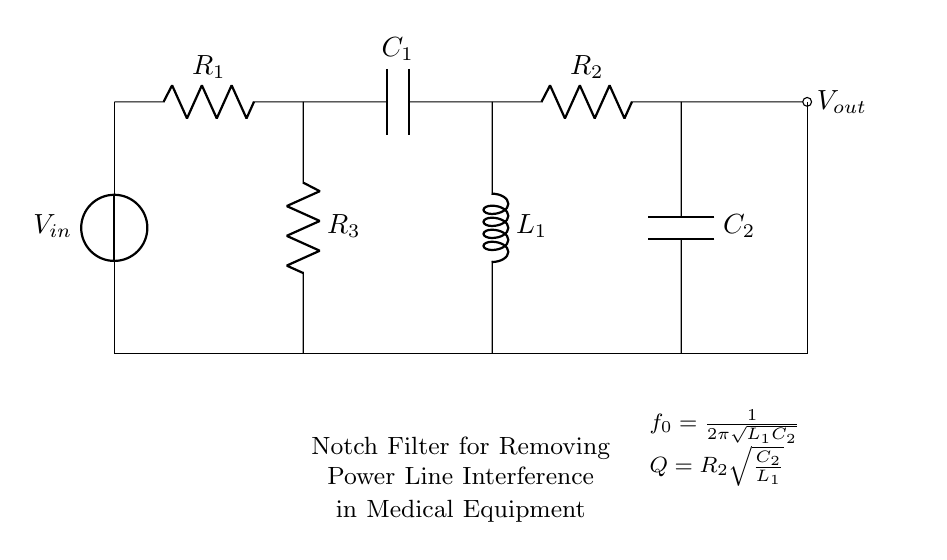What is the input voltage symbol in this circuit? The input voltage is represented by the symbol V_in, indicating the point where the voltage is applied to the circuit.
Answer: V_in What is the output voltage node labeled as? The output voltage node is indicated with the label V_out, which shows where the filtered signal will be taken from the circuit.
Answer: V_out How many resistors are present in the circuit? There are three resistors shown in the circuit: R_1, R_2, and R_3, which are used for impedance and filtering purposes.
Answer: 3 What is the expression for the resonant frequency of the filter? The resonant frequency is given by the formula 1 divided by 2 times pi times the square root of L_1 times C_2, derived from the properties of LC circuits.
Answer: 1 / 2π√(L_1C_2) What defines the quality factor of the notch filter? The quality factor, Q, is defined by the formula R_2 times the square root of C_2 divided by L_1, which measures the selectivity or sharpness of the filter's response.
Answer: R_2√(C_2 / L_1) Which type of circuit is illustrated in the diagram? The circuit is a notch filter specifically designed to remove unwanted power line interference, commonly found at 50 or 60 Hz, which could affect medical equipment performance.
Answer: Notch filter 